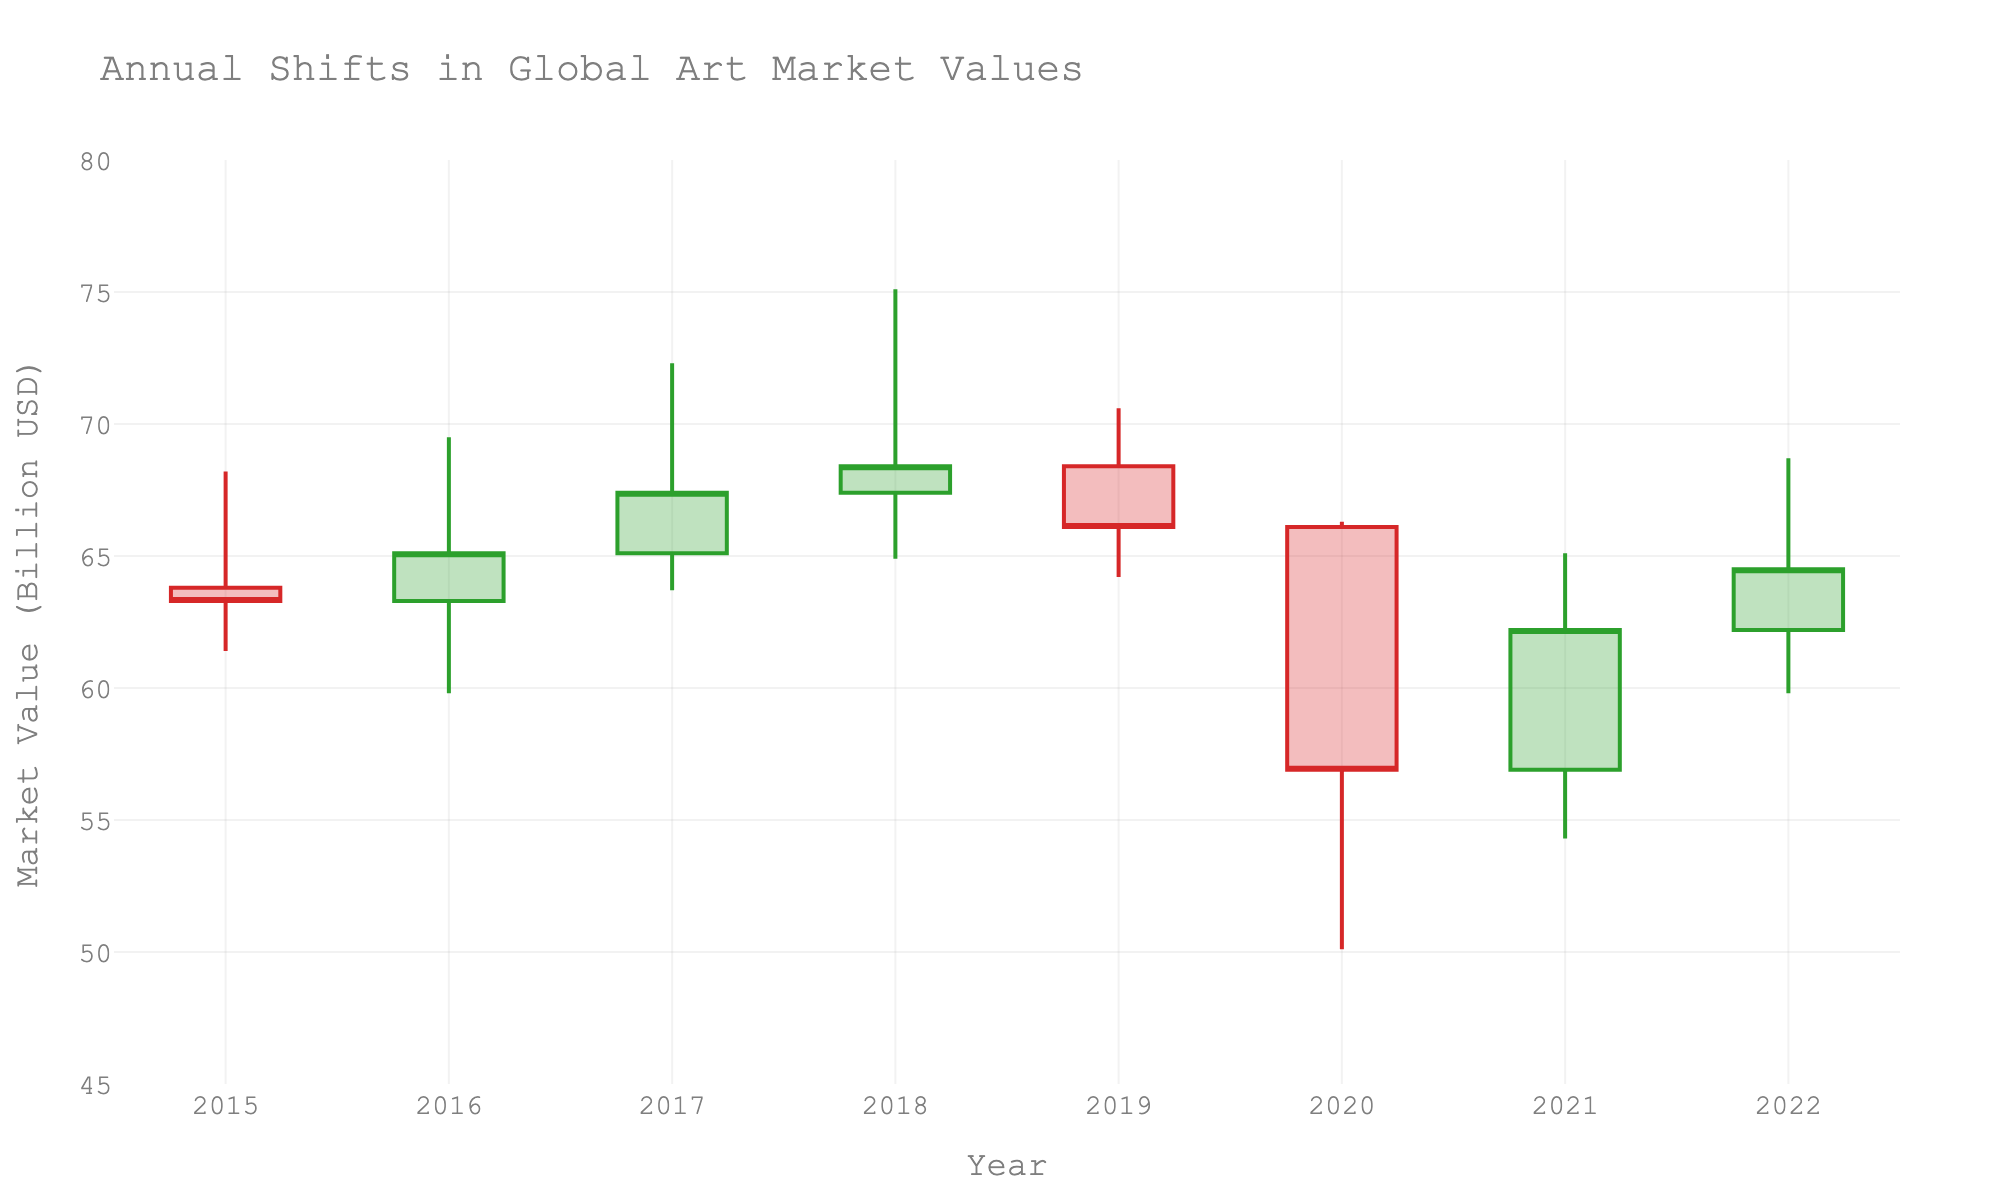What is the title of the figure? The title is usually prominently displayed at the top of the figure. In this case, it is "Annual Shifts in Global Art Market Values".
Answer: Annual Shifts in Global Art Market Values How did the market value close in 2020? The closing value is represented by the last data point on the candlestick for the year 2020. The closing value is around 56.9 billion USD.
Answer: 56.9 billion USD Which year had the highest peak value in the global art market? To find the highest peak value, look at the highest point on the candlesticks across all the years. The year with the highest point is 2018, peaking at 75.1 billion USD.
Answer: 2018 Compare the opening and closing values of the global art market between 2019 and 2020. In which year did the market perform better? For comparison, check the opening and closing values in 2019 and 2020. In 2019, the market opened at 68.4 and closed at 66.1. In 2020, it opened at 66.1 and closed at 56.9. The market performed better in 2019 as it had a higher closing value.
Answer: 2019 What is the trend of the market value from 2015 to 2018? Observe the sequence of the candlestick bars from 2015 to 2018. The opening and closing values are gradually increasing, indicating an upward trend in these years.
Answer: Upward Trend What was the lowest market value recorded, and in which year did it occur? Identify the lowest points of the candlesticks. The lowest value is 50.1 billion USD, which occurred in 2020.
Answer: 50.1 billion USD in 2020 How did the market close in 2021 as compared to its opening value? Look at the opening and closing candlestick segments for 2021. The market opened at 56.9 billion USD and closed at 62.2 billion USD, indicating an increase.
Answer: Increased Which year had the narrowest range (difference between high and low)? To find the narrowest range, calculate the difference between high and low for each year. The year with the smallest difference is 2015, with a range of (68.2 - 61.4) = 6.8 billion USD.
Answer: 2015 Was there any year where the closing value was higher than both the opening and the highest value of the preceding year? Check the closing value of each year and compare it with the opening and highest values of the previous year. In 2016, the closing value (65.1) was higher than both the opening (63.8) and the highest (68.2) values of 2015.
Answer: 2016 Identify the year with the biggest decline from its open to close value. Measure the difference between open and close values for each year. The largest decline is in 2020, with a decrease from 66.1 to 56.9 billion USD.
Answer: 2020 